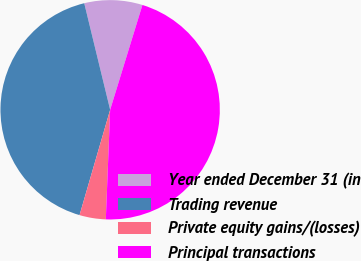Convert chart to OTSL. <chart><loc_0><loc_0><loc_500><loc_500><pie_chart><fcel>Year ended December 31 (in<fcel>Trading revenue<fcel>Private equity gains/(losses)<fcel>Principal transactions<nl><fcel>8.55%<fcel>41.7%<fcel>3.87%<fcel>45.87%<nl></chart> 